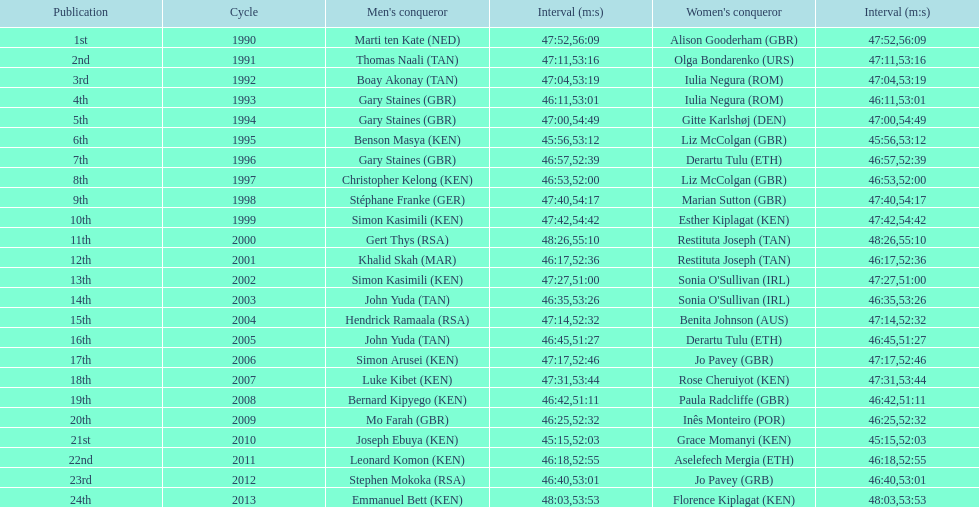What is the difference in finishing times for the men's and women's bupa great south run finish for 2013? 5:50. 